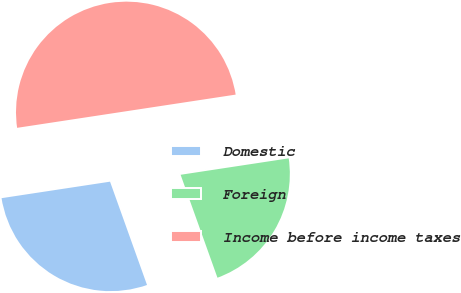Convert chart. <chart><loc_0><loc_0><loc_500><loc_500><pie_chart><fcel>Domestic<fcel>Foreign<fcel>Income before income taxes<nl><fcel>28.07%<fcel>21.93%<fcel>50.0%<nl></chart> 